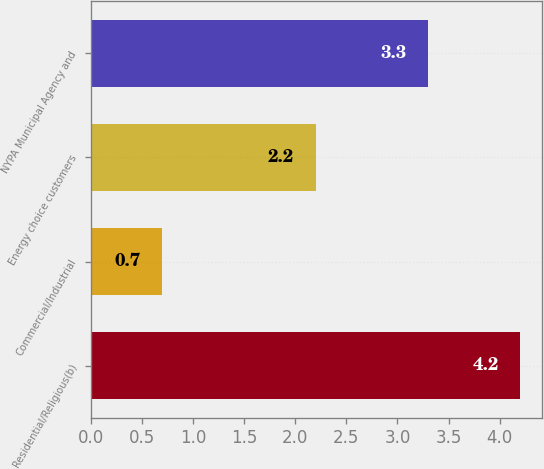<chart> <loc_0><loc_0><loc_500><loc_500><bar_chart><fcel>Residential/Religious(b)<fcel>Commercial/Industrial<fcel>Energy choice customers<fcel>NYPA Municipal Agency and<nl><fcel>4.2<fcel>0.7<fcel>2.2<fcel>3.3<nl></chart> 